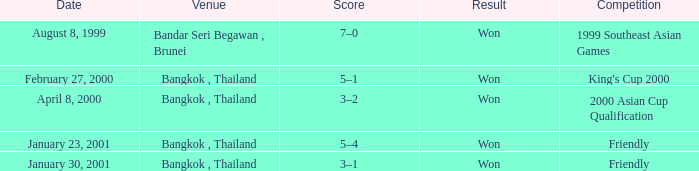What were the points tallied during the 2000 edition of the king's cup? 5–1. 